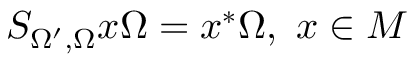<formula> <loc_0><loc_0><loc_500><loc_500>S _ { \Omega ^ { \prime } , \Omega } x \Omega = x ^ { * } \Omega , \, x \in M</formula> 